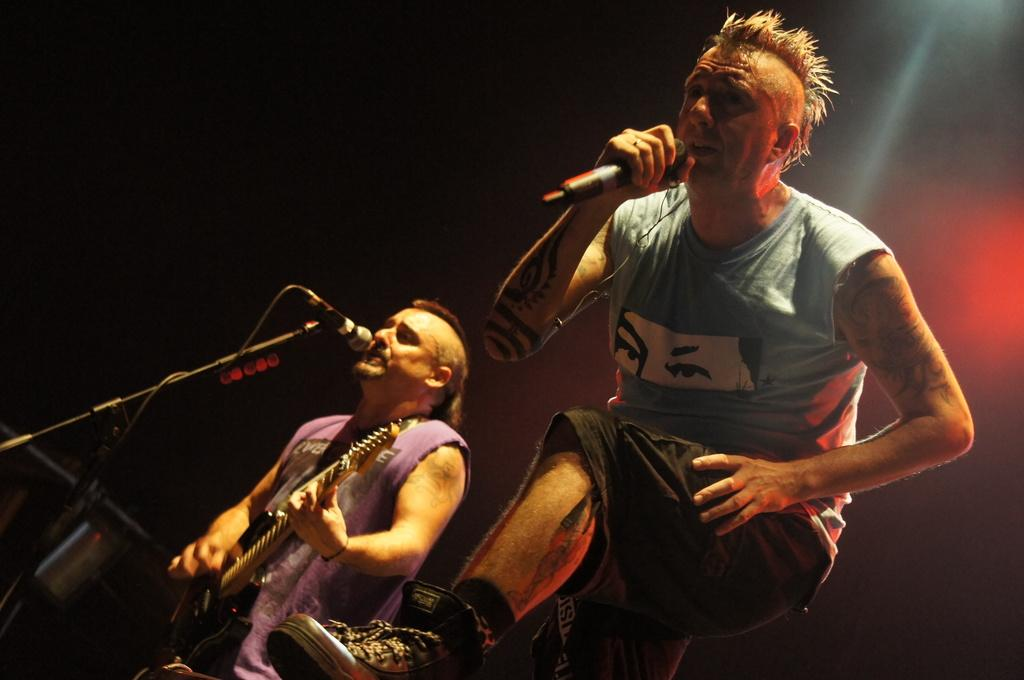How many people are in the image? There are two men in the image. What are the men doing in the image? The men are playing guitar and singing a song. What object is present in the image that is used for amplifying sound? There is a microphone in the image. Can you see a rabbit hopping around the men in the image? No, there is no rabbit present in the image. What type of event are the men participating in, as indicated by the presence of a wristband? There is no mention of a wristband or any event in the image. 